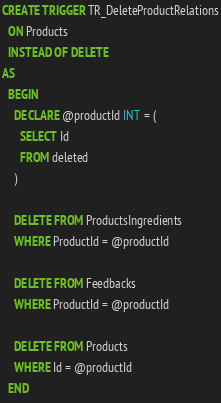Convert code to text. <code><loc_0><loc_0><loc_500><loc_500><_SQL_>CREATE TRIGGER TR_DeleteProductRelations
  ON Products
  INSTEAD OF DELETE
AS
  BEGIN
    DECLARE @productId INT = (
      SELECT Id
      FROM deleted
    )

    DELETE FROM ProductsIngredients
    WHERE ProductId = @productId

    DELETE FROM Feedbacks
    WHERE ProductId = @productId

    DELETE FROM Products
    WHERE Id = @productId
  END</code> 